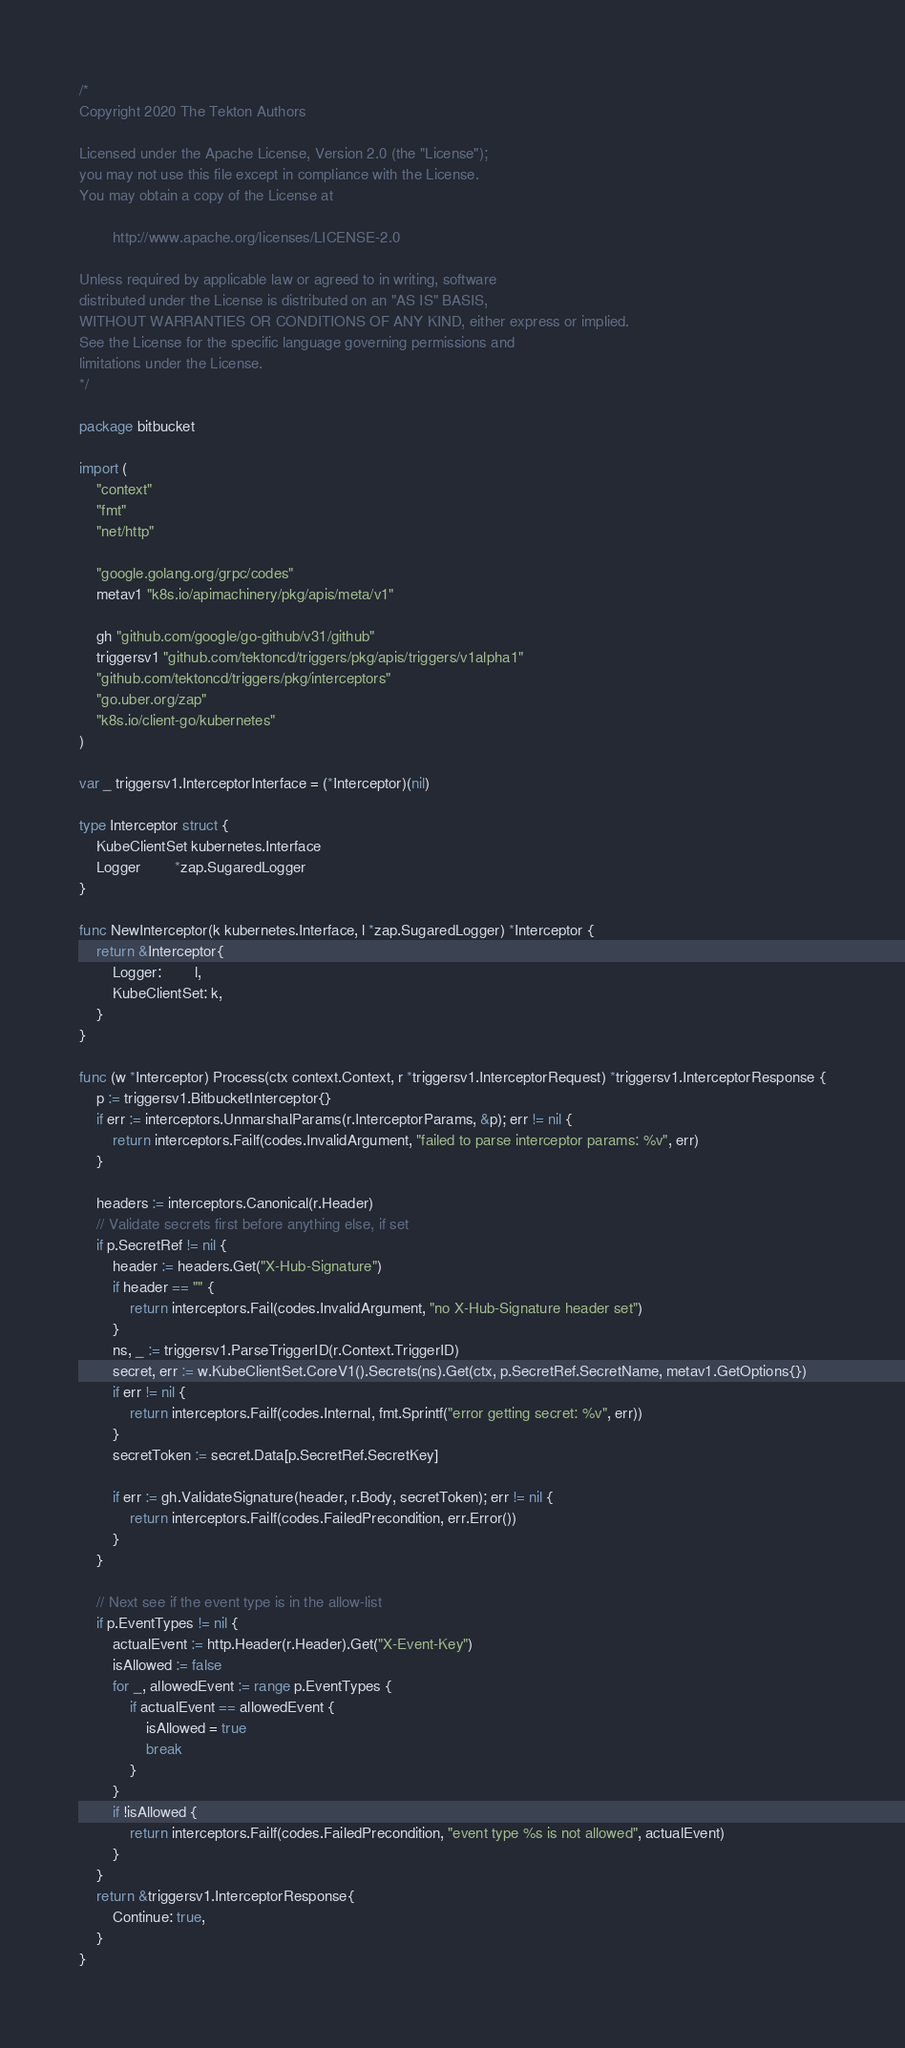<code> <loc_0><loc_0><loc_500><loc_500><_Go_>/*
Copyright 2020 The Tekton Authors

Licensed under the Apache License, Version 2.0 (the "License");
you may not use this file except in compliance with the License.
You may obtain a copy of the License at

		http://www.apache.org/licenses/LICENSE-2.0

Unless required by applicable law or agreed to in writing, software
distributed under the License is distributed on an "AS IS" BASIS,
WITHOUT WARRANTIES OR CONDITIONS OF ANY KIND, either express or implied.
See the License for the specific language governing permissions and
limitations under the License.
*/

package bitbucket

import (
	"context"
	"fmt"
	"net/http"

	"google.golang.org/grpc/codes"
	metav1 "k8s.io/apimachinery/pkg/apis/meta/v1"

	gh "github.com/google/go-github/v31/github"
	triggersv1 "github.com/tektoncd/triggers/pkg/apis/triggers/v1alpha1"
	"github.com/tektoncd/triggers/pkg/interceptors"
	"go.uber.org/zap"
	"k8s.io/client-go/kubernetes"
)

var _ triggersv1.InterceptorInterface = (*Interceptor)(nil)

type Interceptor struct {
	KubeClientSet kubernetes.Interface
	Logger        *zap.SugaredLogger
}

func NewInterceptor(k kubernetes.Interface, l *zap.SugaredLogger) *Interceptor {
	return &Interceptor{
		Logger:        l,
		KubeClientSet: k,
	}
}

func (w *Interceptor) Process(ctx context.Context, r *triggersv1.InterceptorRequest) *triggersv1.InterceptorResponse {
	p := triggersv1.BitbucketInterceptor{}
	if err := interceptors.UnmarshalParams(r.InterceptorParams, &p); err != nil {
		return interceptors.Failf(codes.InvalidArgument, "failed to parse interceptor params: %v", err)
	}

	headers := interceptors.Canonical(r.Header)
	// Validate secrets first before anything else, if set
	if p.SecretRef != nil {
		header := headers.Get("X-Hub-Signature")
		if header == "" {
			return interceptors.Fail(codes.InvalidArgument, "no X-Hub-Signature header set")
		}
		ns, _ := triggersv1.ParseTriggerID(r.Context.TriggerID)
		secret, err := w.KubeClientSet.CoreV1().Secrets(ns).Get(ctx, p.SecretRef.SecretName, metav1.GetOptions{})
		if err != nil {
			return interceptors.Failf(codes.Internal, fmt.Sprintf("error getting secret: %v", err))
		}
		secretToken := secret.Data[p.SecretRef.SecretKey]

		if err := gh.ValidateSignature(header, r.Body, secretToken); err != nil {
			return interceptors.Failf(codes.FailedPrecondition, err.Error())
		}
	}

	// Next see if the event type is in the allow-list
	if p.EventTypes != nil {
		actualEvent := http.Header(r.Header).Get("X-Event-Key")
		isAllowed := false
		for _, allowedEvent := range p.EventTypes {
			if actualEvent == allowedEvent {
				isAllowed = true
				break
			}
		}
		if !isAllowed {
			return interceptors.Failf(codes.FailedPrecondition, "event type %s is not allowed", actualEvent)
		}
	}
	return &triggersv1.InterceptorResponse{
		Continue: true,
	}
}
</code> 